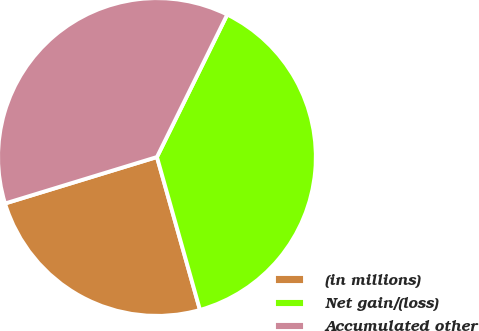Convert chart. <chart><loc_0><loc_0><loc_500><loc_500><pie_chart><fcel>(in millions)<fcel>Net gain/(loss)<fcel>Accumulated other<nl><fcel>24.64%<fcel>38.34%<fcel>37.02%<nl></chart> 